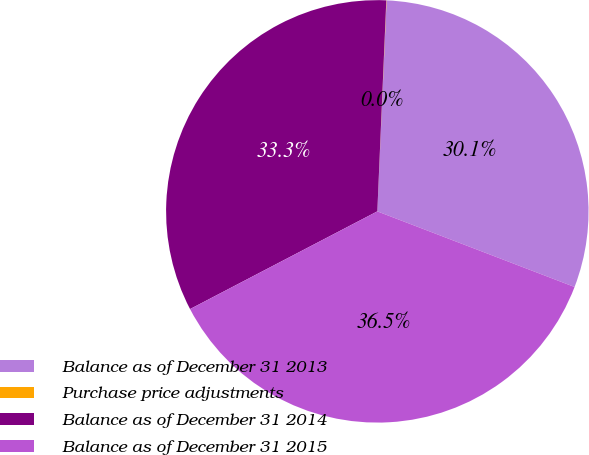Convert chart. <chart><loc_0><loc_0><loc_500><loc_500><pie_chart><fcel>Balance as of December 31 2013<fcel>Purchase price adjustments<fcel>Balance as of December 31 2014<fcel>Balance as of December 31 2015<nl><fcel>30.13%<fcel>0.02%<fcel>33.33%<fcel>36.52%<nl></chart> 